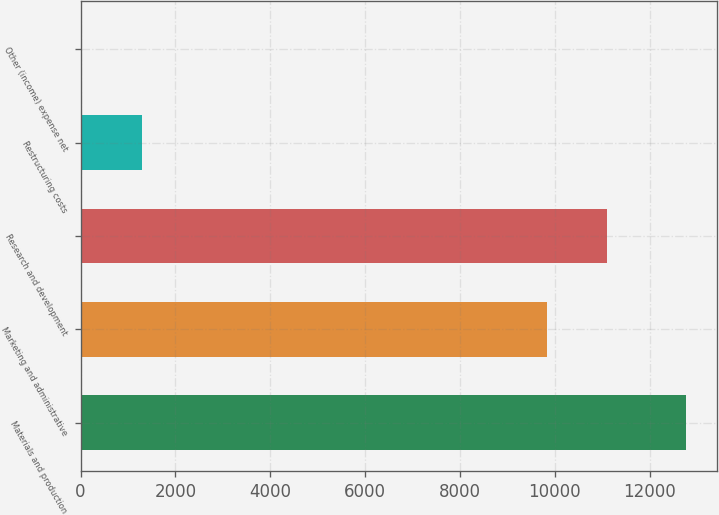Convert chart to OTSL. <chart><loc_0><loc_0><loc_500><loc_500><bar_chart><fcel>Materials and production<fcel>Marketing and administrative<fcel>Research and development<fcel>Restructuring costs<fcel>Other (income) expense net<nl><fcel>12775<fcel>9830<fcel>11106.3<fcel>1288.3<fcel>12<nl></chart> 